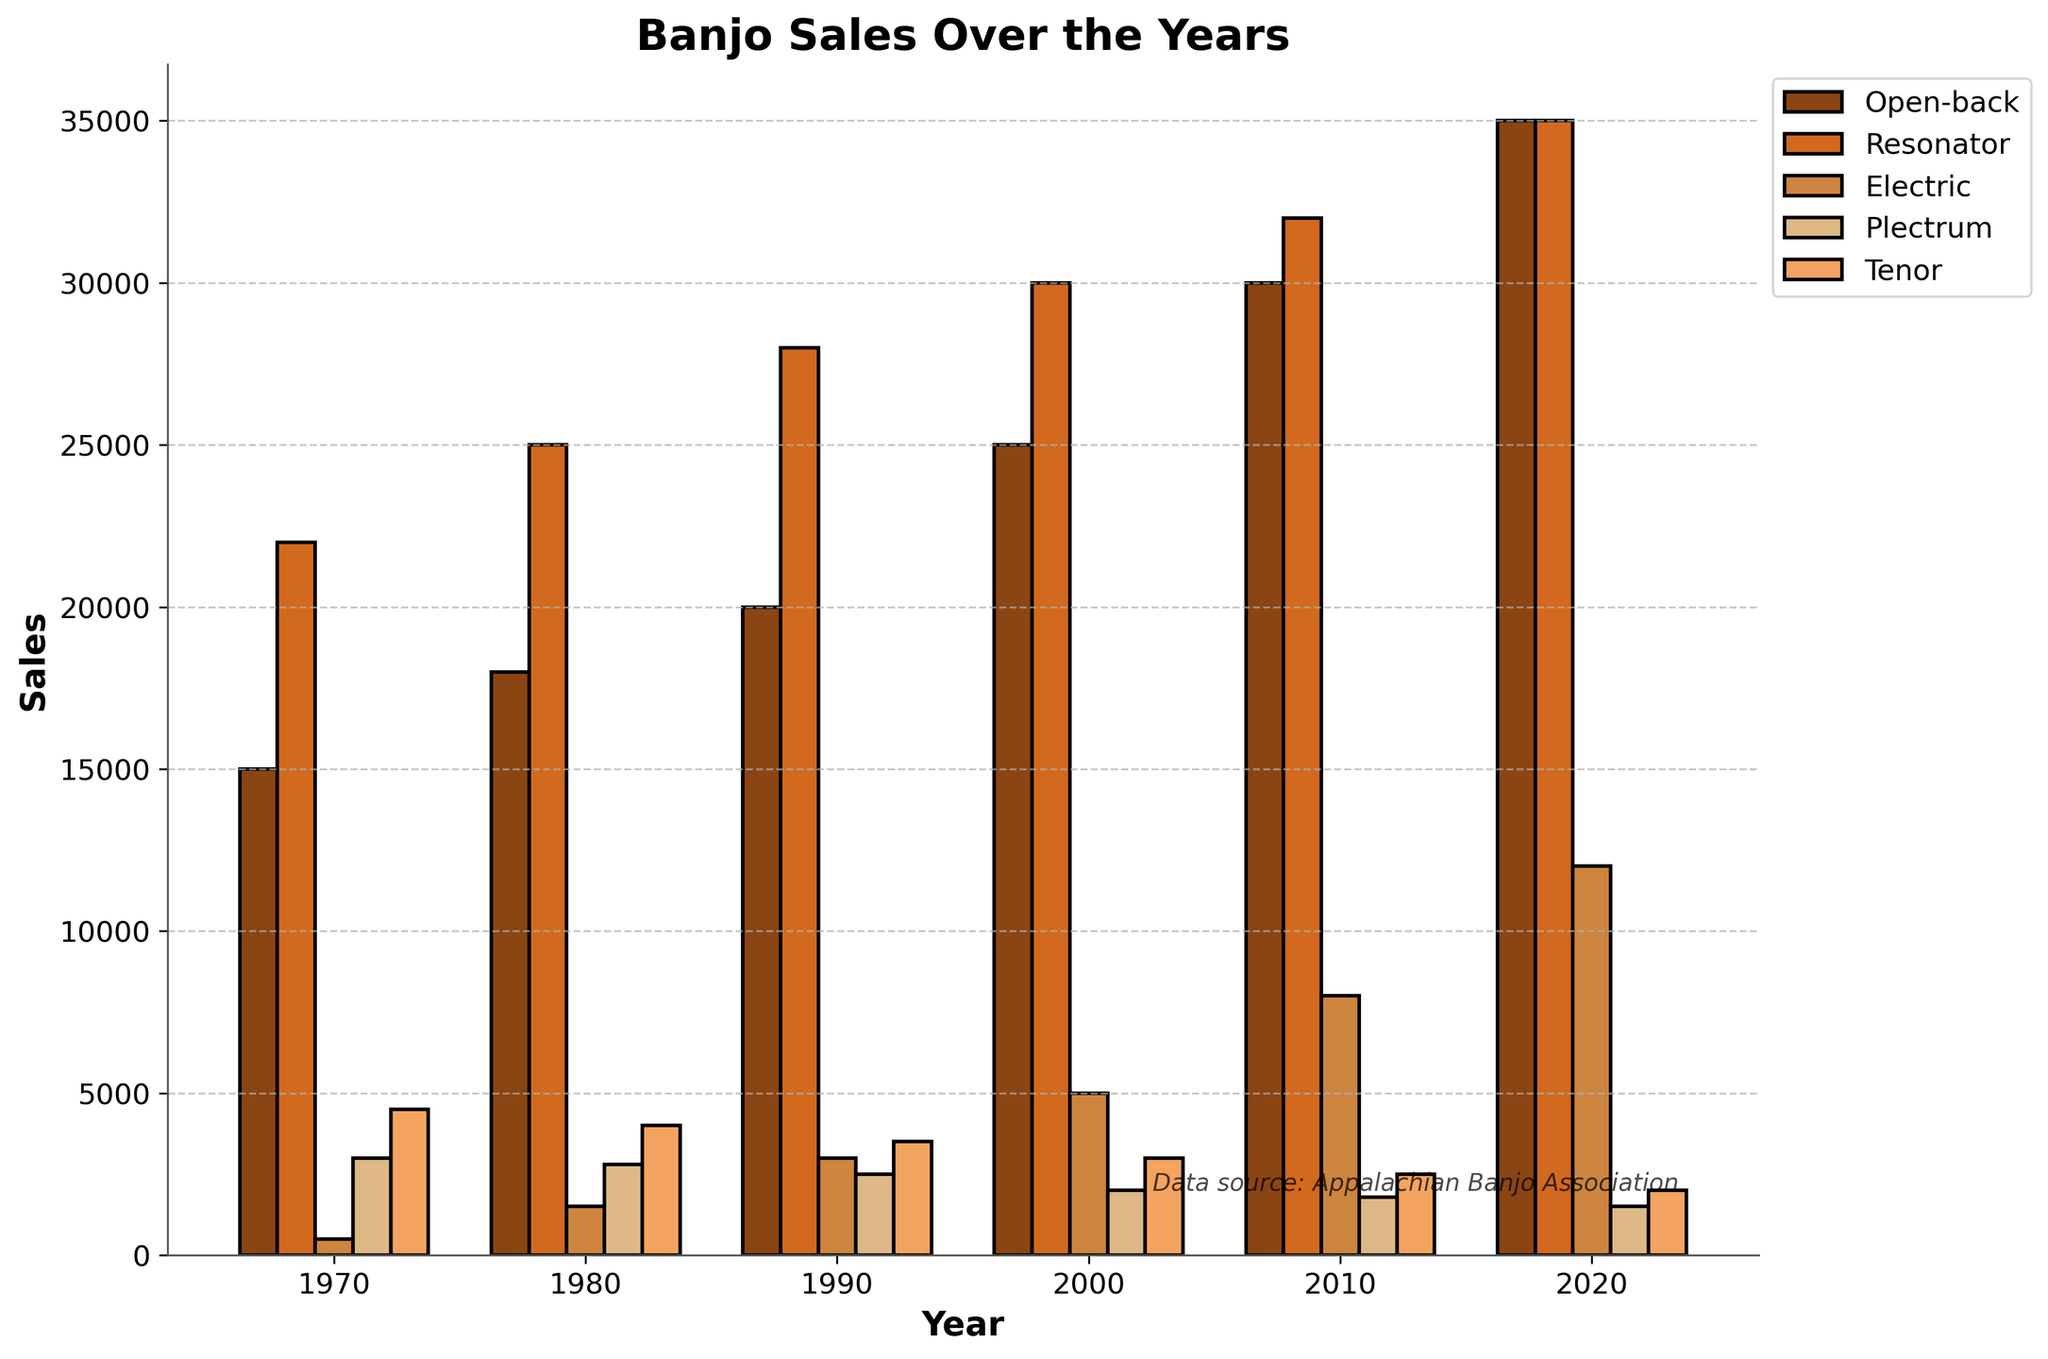Which banjo type showed the most consistent increase in sales over the years? By observing the height of the bars for each type of banjo across the years, we can see that "Open-back" banjo sales show a steady and consistent increase every decade.
Answer: Open-back How did the sales of electric banjos compare to resonator banjos in 2020? In 2020, the height of the bar for electric banjos is shorter than the resonator banjos. To be specific, electric banjo sales were 12,000 units, while resonator banjo sales were 35,000 units.
Answer: Resonator banjos had higher sales What is the total sales of plectrum and tenor banjo sales in 1990? By adding the heights of the bars representing plectrum and tenor banjo sales in 1990, we find that plectrum banjos sold 2,500 units and tenor banjos sold 3,500 units, resulting in a total of 6,000 units.
Answer: 6,000 units Did any of the banjo types experience a decrease in sales between 1980 and 1990? Comparing the heights of the bars, none of the banjo types experienced a decrease; all types had an increase in sales from 1980 to 1990.
Answer: No Which year had the highest total sales across all banjo types? Adding up the heights of the bars for each year, 2020 has the highest total sales with sales figures from all banjo types being higher cumulatively.
Answer: 2020 What color represents the resonator banjos in the chart? The color associated with the resonator banjos in the chart is observed by looking at the legend, which shows they are represented by a brownish color.
Answer: Brownish By what amount did open-back banjo sales increase from 2000 to 2010? The height of the bar for open-back banjos in 2000 is 25,000 units and it increases to 30,000 units in 2010, so the increase is 5,000 units.
Answer: 5,000 units What were the total sales of all banjo types in the year 2000? Summing up the sales figures for each type of banjo in the year 2000: Open-back (25,000) + Resonator (30,000) + Electric (5,000) + Plectrum (2,000) + Tenor (3,000) gives 65,000 units.
Answer: 65,000 units How do the sales figures for plectrum banjos in 1980 compare to those in 1970? The height of the bar for plectrum banjos in 1980 is slightly lower than that in 1970. Specifically, plectrum banjo sales were 2,800 units in 1980 and 3,000 units in 1970.
Answer: Lower in 1980 